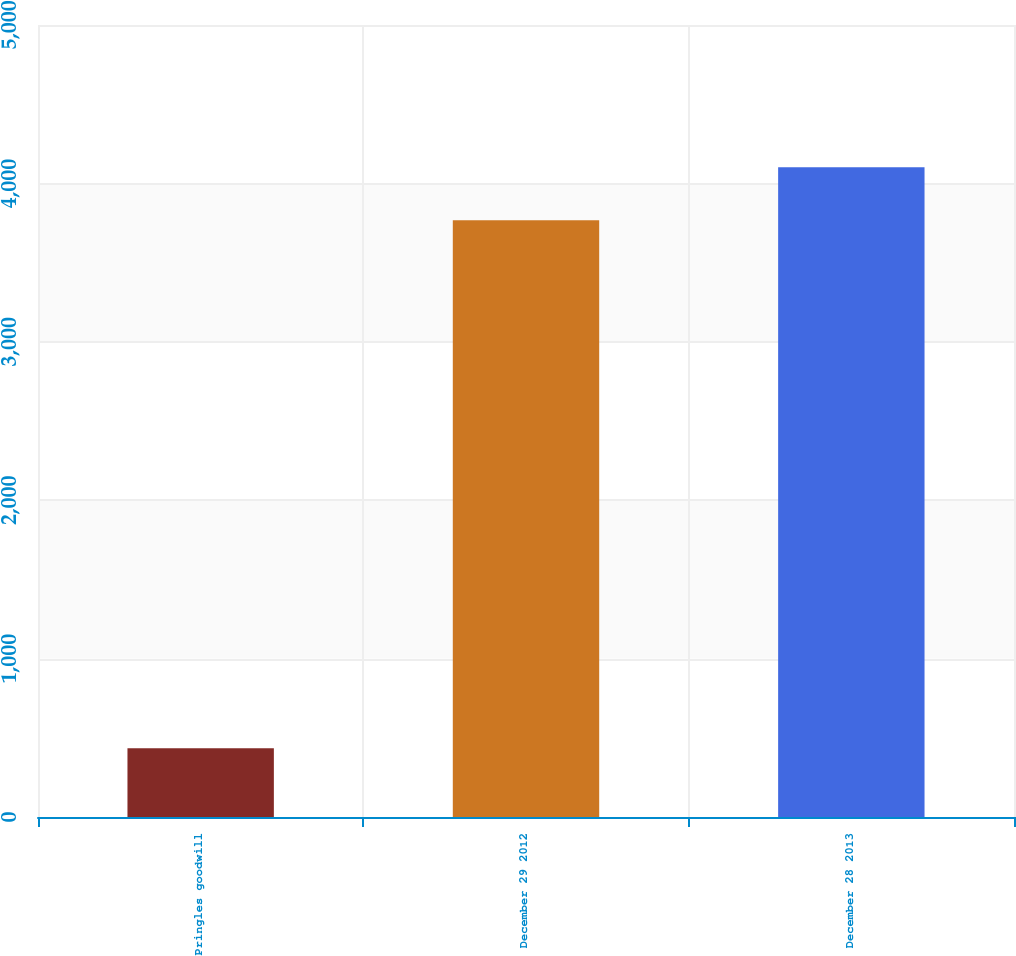Convert chart to OTSL. <chart><loc_0><loc_0><loc_500><loc_500><bar_chart><fcel>Pringles goodwill<fcel>December 29 2012<fcel>December 28 2013<nl><fcel>434<fcel>3767<fcel>4101.5<nl></chart> 